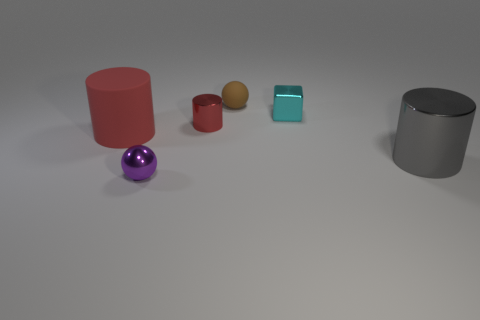Do the cyan metallic cube and the gray thing have the same size?
Offer a terse response. No. What shape is the brown thing that is the same material as the big red object?
Make the answer very short. Sphere. What number of other things are the same shape as the large red object?
Your answer should be very brief. 2. There is a large object that is right of the small ball behind the rubber thing that is left of the small red metal object; what is its shape?
Give a very brief answer. Cylinder. What number of cubes are large blue matte things or big matte objects?
Provide a short and direct response. 0. Are there any large gray metal cylinders in front of the large object on the right side of the tiny cyan cube?
Provide a succinct answer. No. Is there anything else that is made of the same material as the small purple sphere?
Your answer should be compact. Yes. There is a tiny cyan thing; is its shape the same as the matte object to the left of the purple ball?
Offer a terse response. No. What number of other things are the same size as the cyan shiny block?
Keep it short and to the point. 3. How many blue objects are either tiny cubes or small rubber things?
Ensure brevity in your answer.  0. 